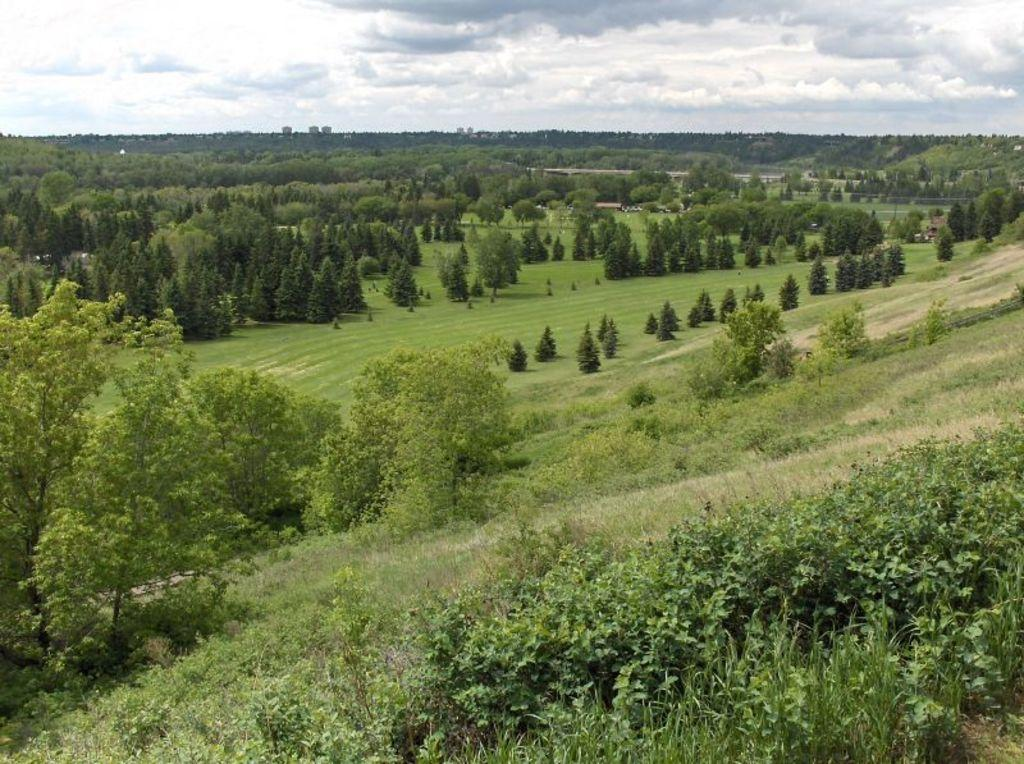What type of vegetation can be seen in the image? There are trees, grass, and plants in the image. What part of the natural environment is visible in the image? The sky is visible at the top of the image. Who is the creator of the cabbage in the image? There is no cabbage present in the image, so it is not possible to determine who its creator might be. 